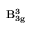<formula> <loc_0><loc_0><loc_500><loc_500>B _ { 3 g } ^ { 3 }</formula> 